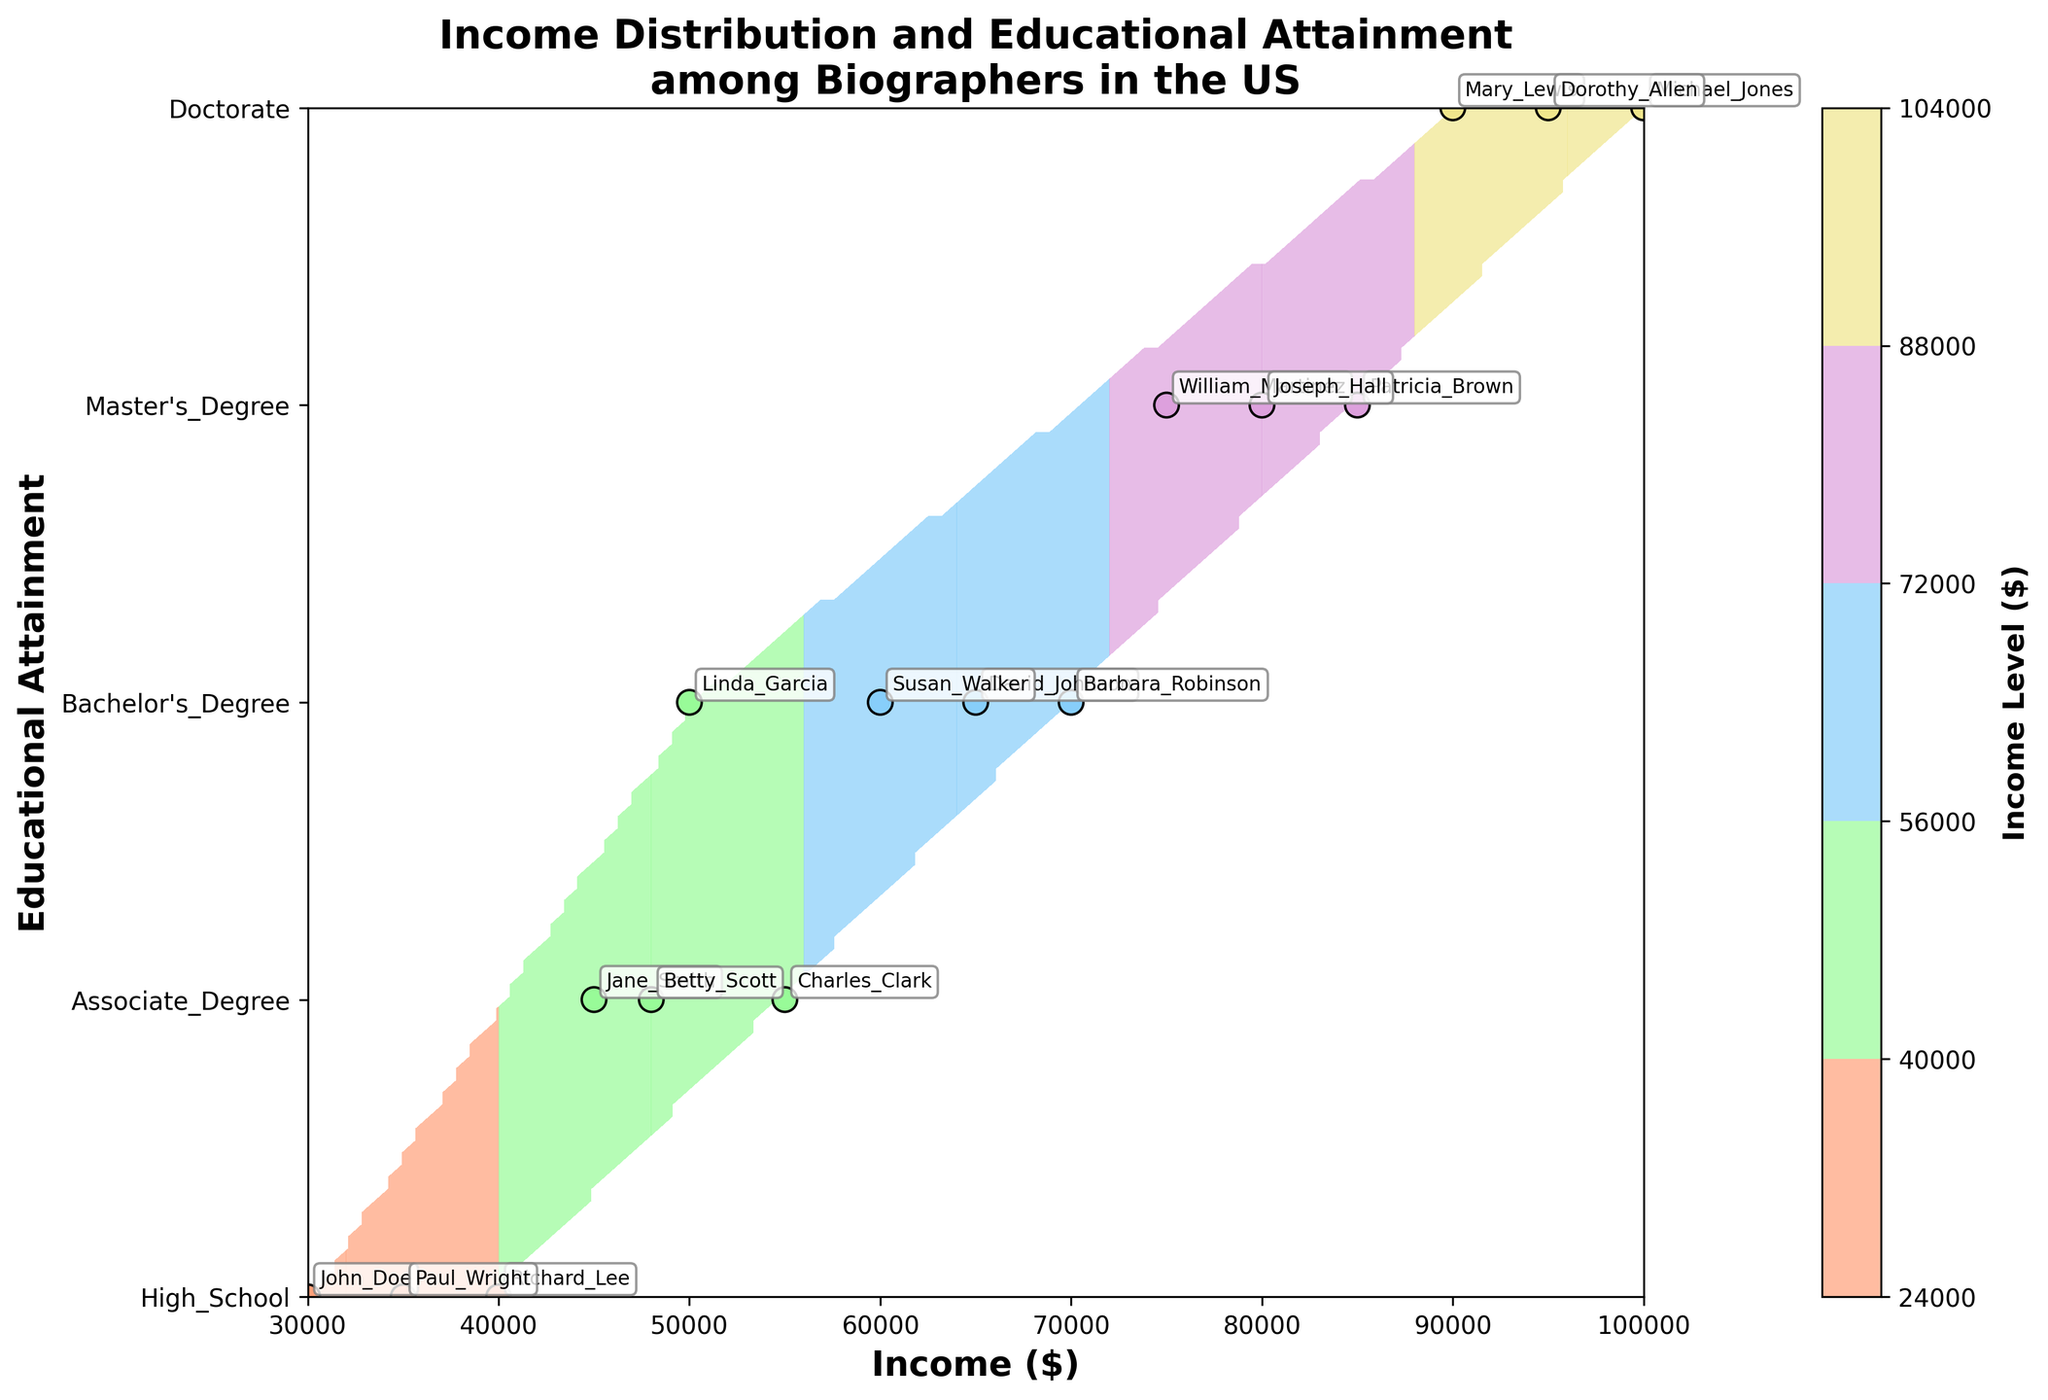What is the title of the plot? The title of the plot is located at the top center of the figure and provides an overview of the subject, which is "Income Distribution and Educational Attainment among Biographers in the US".
Answer: Income Distribution and Educational Attainment among Biographers in the US How is the x-axis labeled? The x-axis label provides information about the variable it represents. In this plot, the x-axis is labeled "Income ($)", indicating that it shows the income levels of biographers.
Answer: Income ($) How many levels of educational attainment are represented on the y-axis? The y-axis has custom y-ticks representing different levels of educational attainment. By counting the distinct labels, we see High School, Associate Degree, Bachelor's Degree, Master's Degree, and Doctorate.
Answer: 5 What is the income range of biographers with a Bachelor's Degree? To determine the income range for biographers with a Bachelor's Degree, identify the scatter points along the y-axis at the Bachelor's Degree level. The incomes are 65000, 50000, 70000, and 60000. Therefore, the range is from the minimum of 50000 to the maximum of 70000.
Answer: 50000 to 70000 Which biographer has the highest income and what is their educational attainment? Locate the scatter point at the highest income level on the x-axis, which represents 100000, and identify the corresponding educational attainment on the y-axis. The label for this point indicates "Michael_Jones", and their educational attainment is "Doctorate".
Answer: Michael_Jones, Doctorate Are there more biographers with a Master's Degree or a Doctorate? Count the scatter points at the y-axis levels for Master's Degree and Doctorate. There are three points at the Master's Degree level (Patricia_Brown, William_Martinez, Joseph_Hall) and three points at the Doctorate level (Michael_Jones, Mary_Lewis, Dorothy_Allen). Both levels have the same number of biographers.
Answer: Same What is the average income of biographers with a High School education? Identify the incomes for biographers with a High School education: 30000 (John_Doe), 40000 (Richard_Lee), and 35000 (Paul_Wright). Sum these amounts and divide by the number of biographers at this education level (3). Calculation: (30000 + 40000 + 35000) / 3 = 105000 / 3 = 35000.
Answer: 35000 How does the income distribution for biographers with an Associate Degree compare to those with a Doctorate? Count the scatter points for both educational levels. For Associate Degree, there are Charles_Clark (55000), Jane_Smith (45000), and Betty_Scott (48000). For Doctorate, there are Michael_Jones (100000), Mary_Lewis (90000), and Dorothy_Allen (95000). Compare the income ranges: Associate Degree ranges from 45000 to 55000, while Doctorate ranges from 90000 to 100000. The income distribution for Doctorate degrees is higher.
Answer: Doctorate is higher 